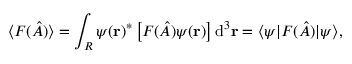<formula> <loc_0><loc_0><loc_500><loc_500>\langle F ( { \hat { A } } ) \rangle = \int _ { R } \psi ( r ) ^ { * } \left [ F ( { \hat { A } } ) \psi ( r ) \right ] d ^ { 3 } r = \langle \psi | F ( { \hat { A } } ) | \psi \rangle ,</formula> 